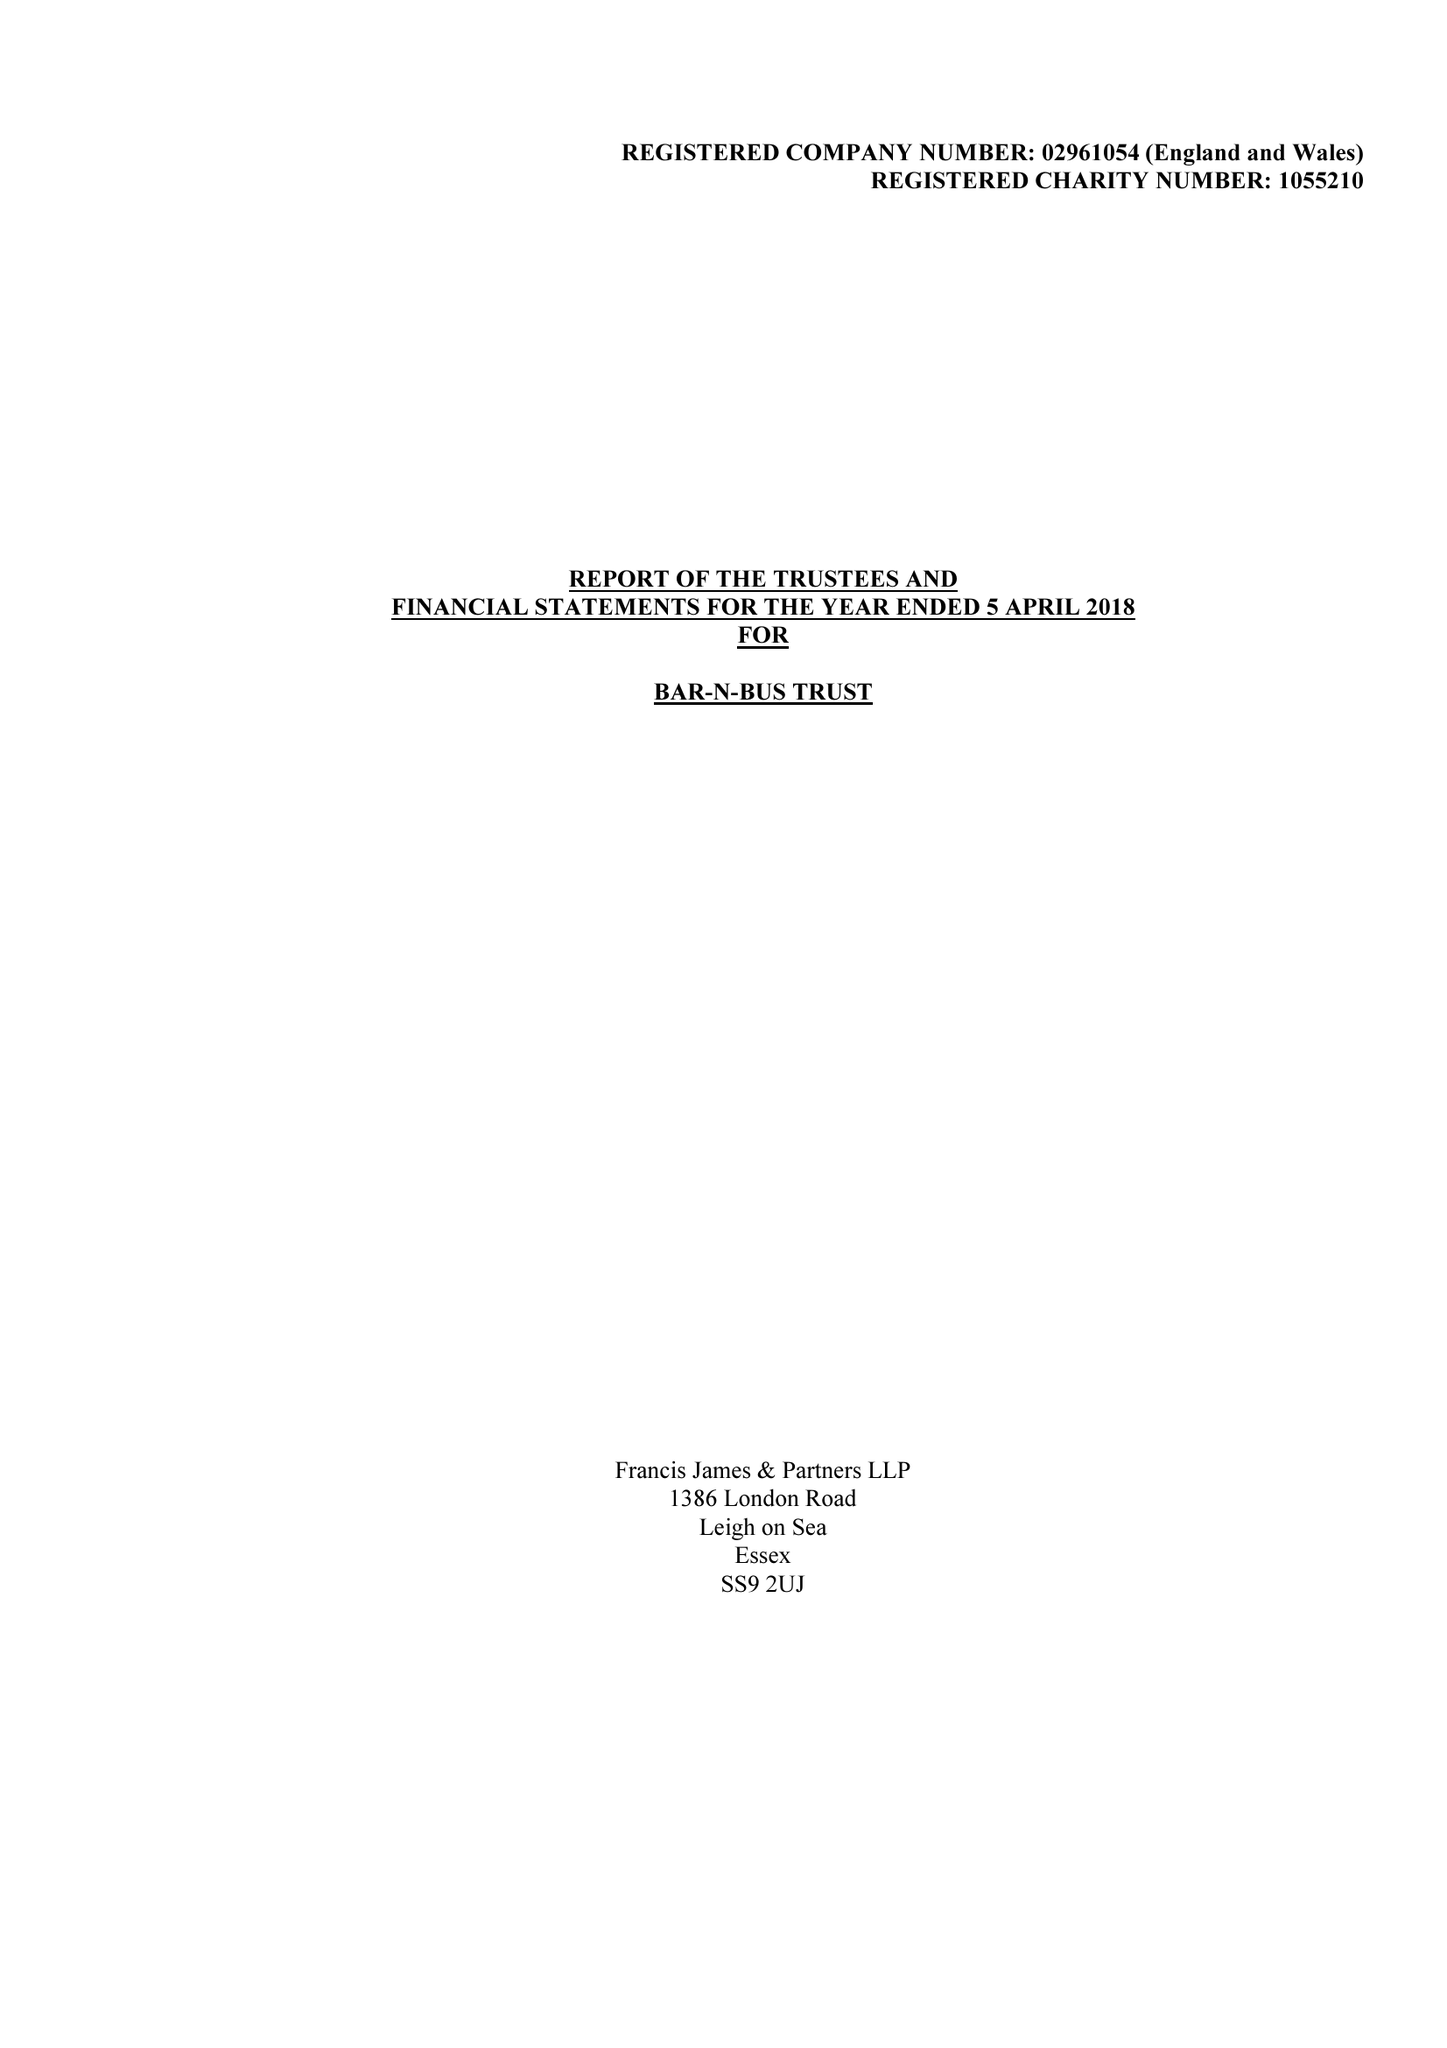What is the value for the address__post_town?
Answer the question using a single word or phrase. WESTCLIFF-ON-SEA 